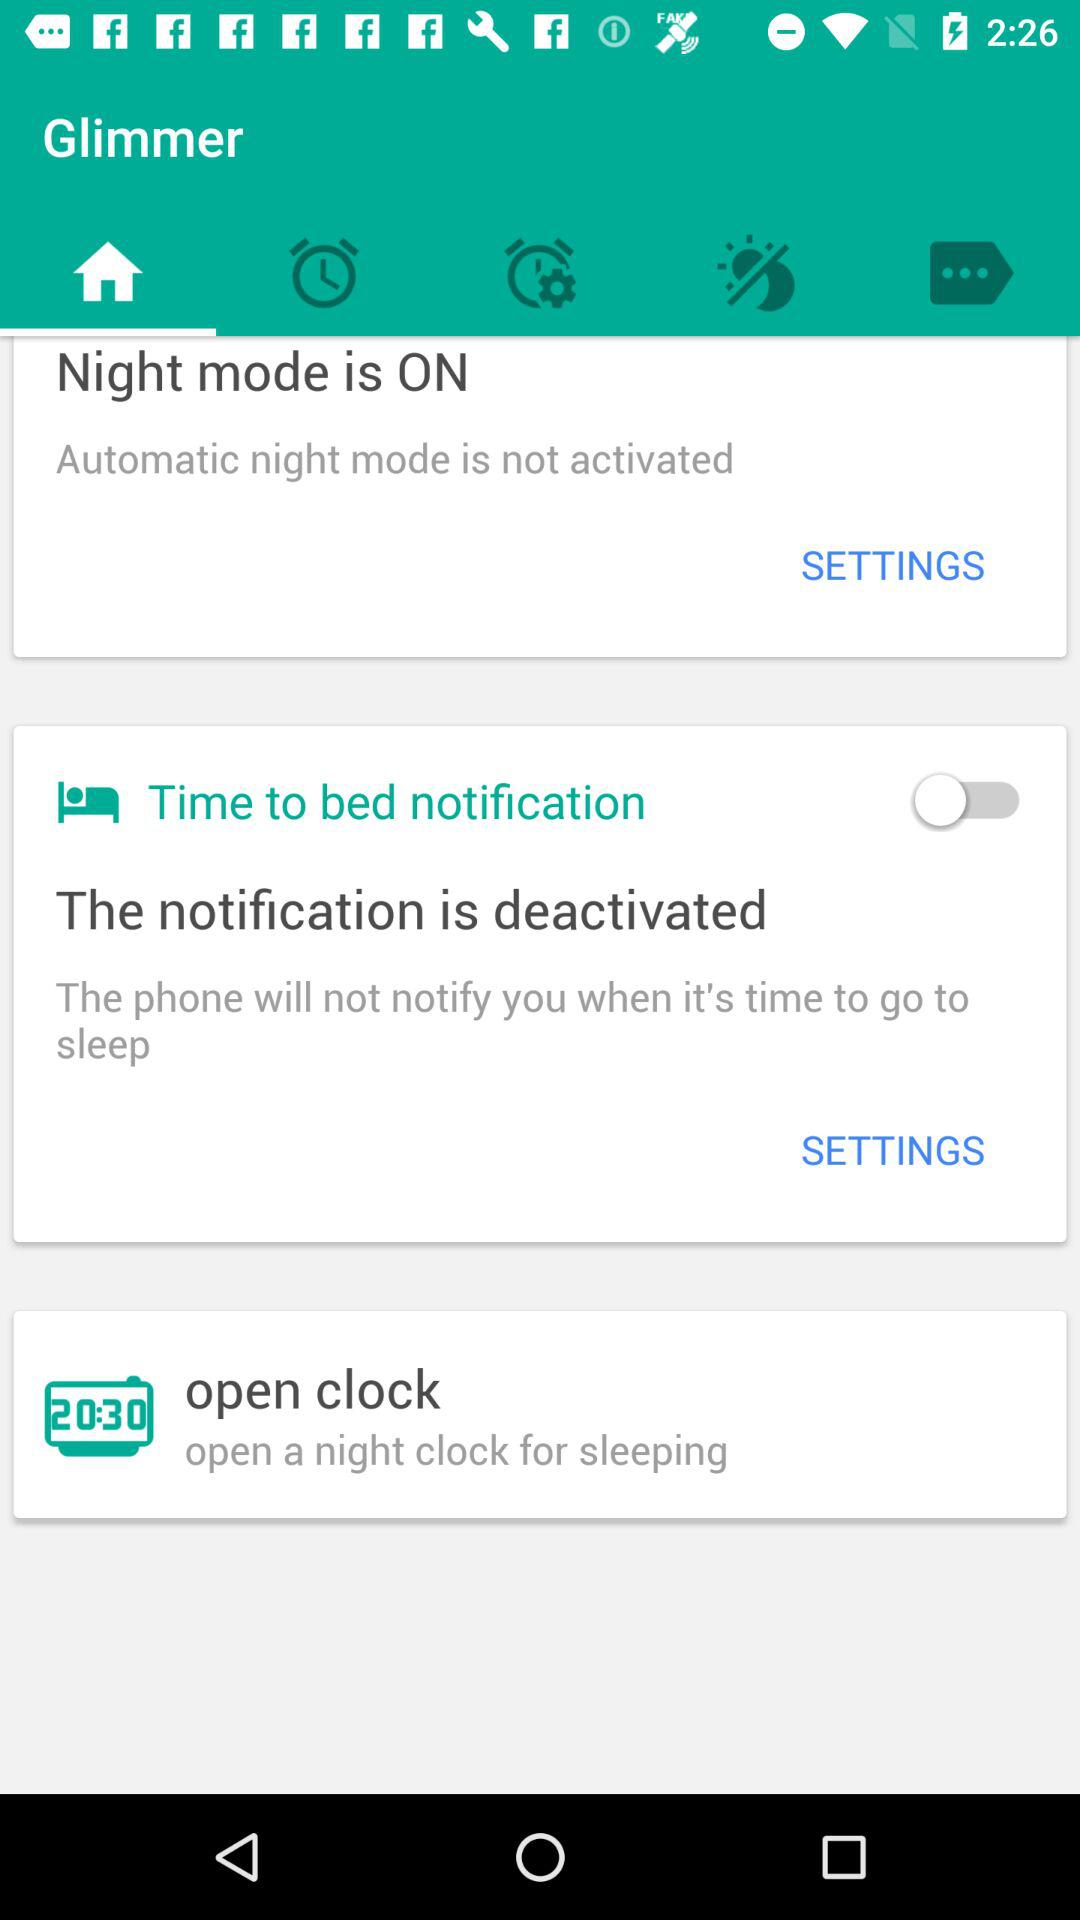What is the setting for the notification? The setting for the notification is "deactivated". 